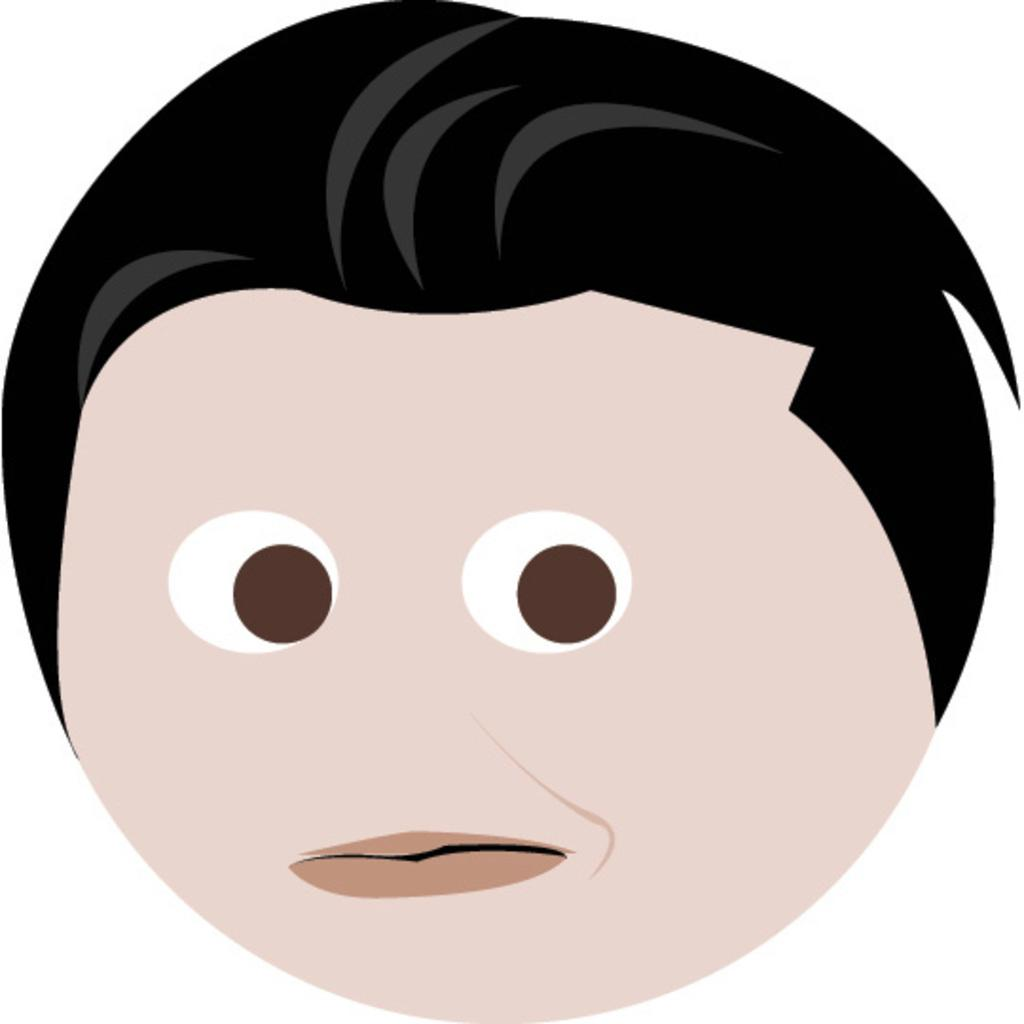What type of image is being described? The image is animated. What is the main subject of the image? The image depicts a person's face. Where is the wound located on the person's face in the image? There is no wound present on the person's face in the image. What place is the person's face in the image? The person's face is the main subject of the image, so it is not accurate to describe it as being in a specific place within the image. 